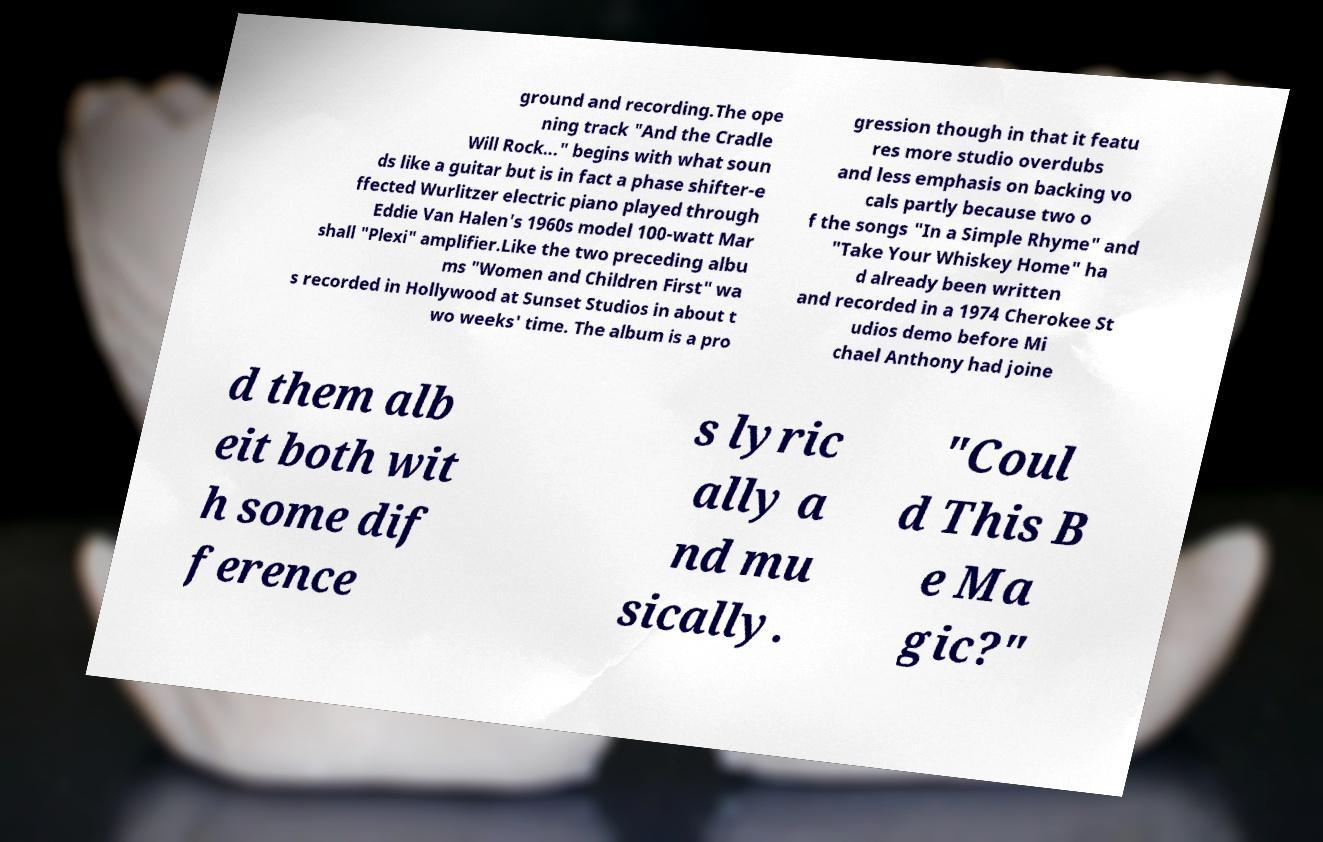Could you assist in decoding the text presented in this image and type it out clearly? ground and recording.The ope ning track "And the Cradle Will Rock..." begins with what soun ds like a guitar but is in fact a phase shifter-e ffected Wurlitzer electric piano played through Eddie Van Halen's 1960s model 100-watt Mar shall "Plexi" amplifier.Like the two preceding albu ms "Women and Children First" wa s recorded in Hollywood at Sunset Studios in about t wo weeks' time. The album is a pro gression though in that it featu res more studio overdubs and less emphasis on backing vo cals partly because two o f the songs "In a Simple Rhyme" and "Take Your Whiskey Home" ha d already been written and recorded in a 1974 Cherokee St udios demo before Mi chael Anthony had joine d them alb eit both wit h some dif ference s lyric ally a nd mu sically. "Coul d This B e Ma gic?" 